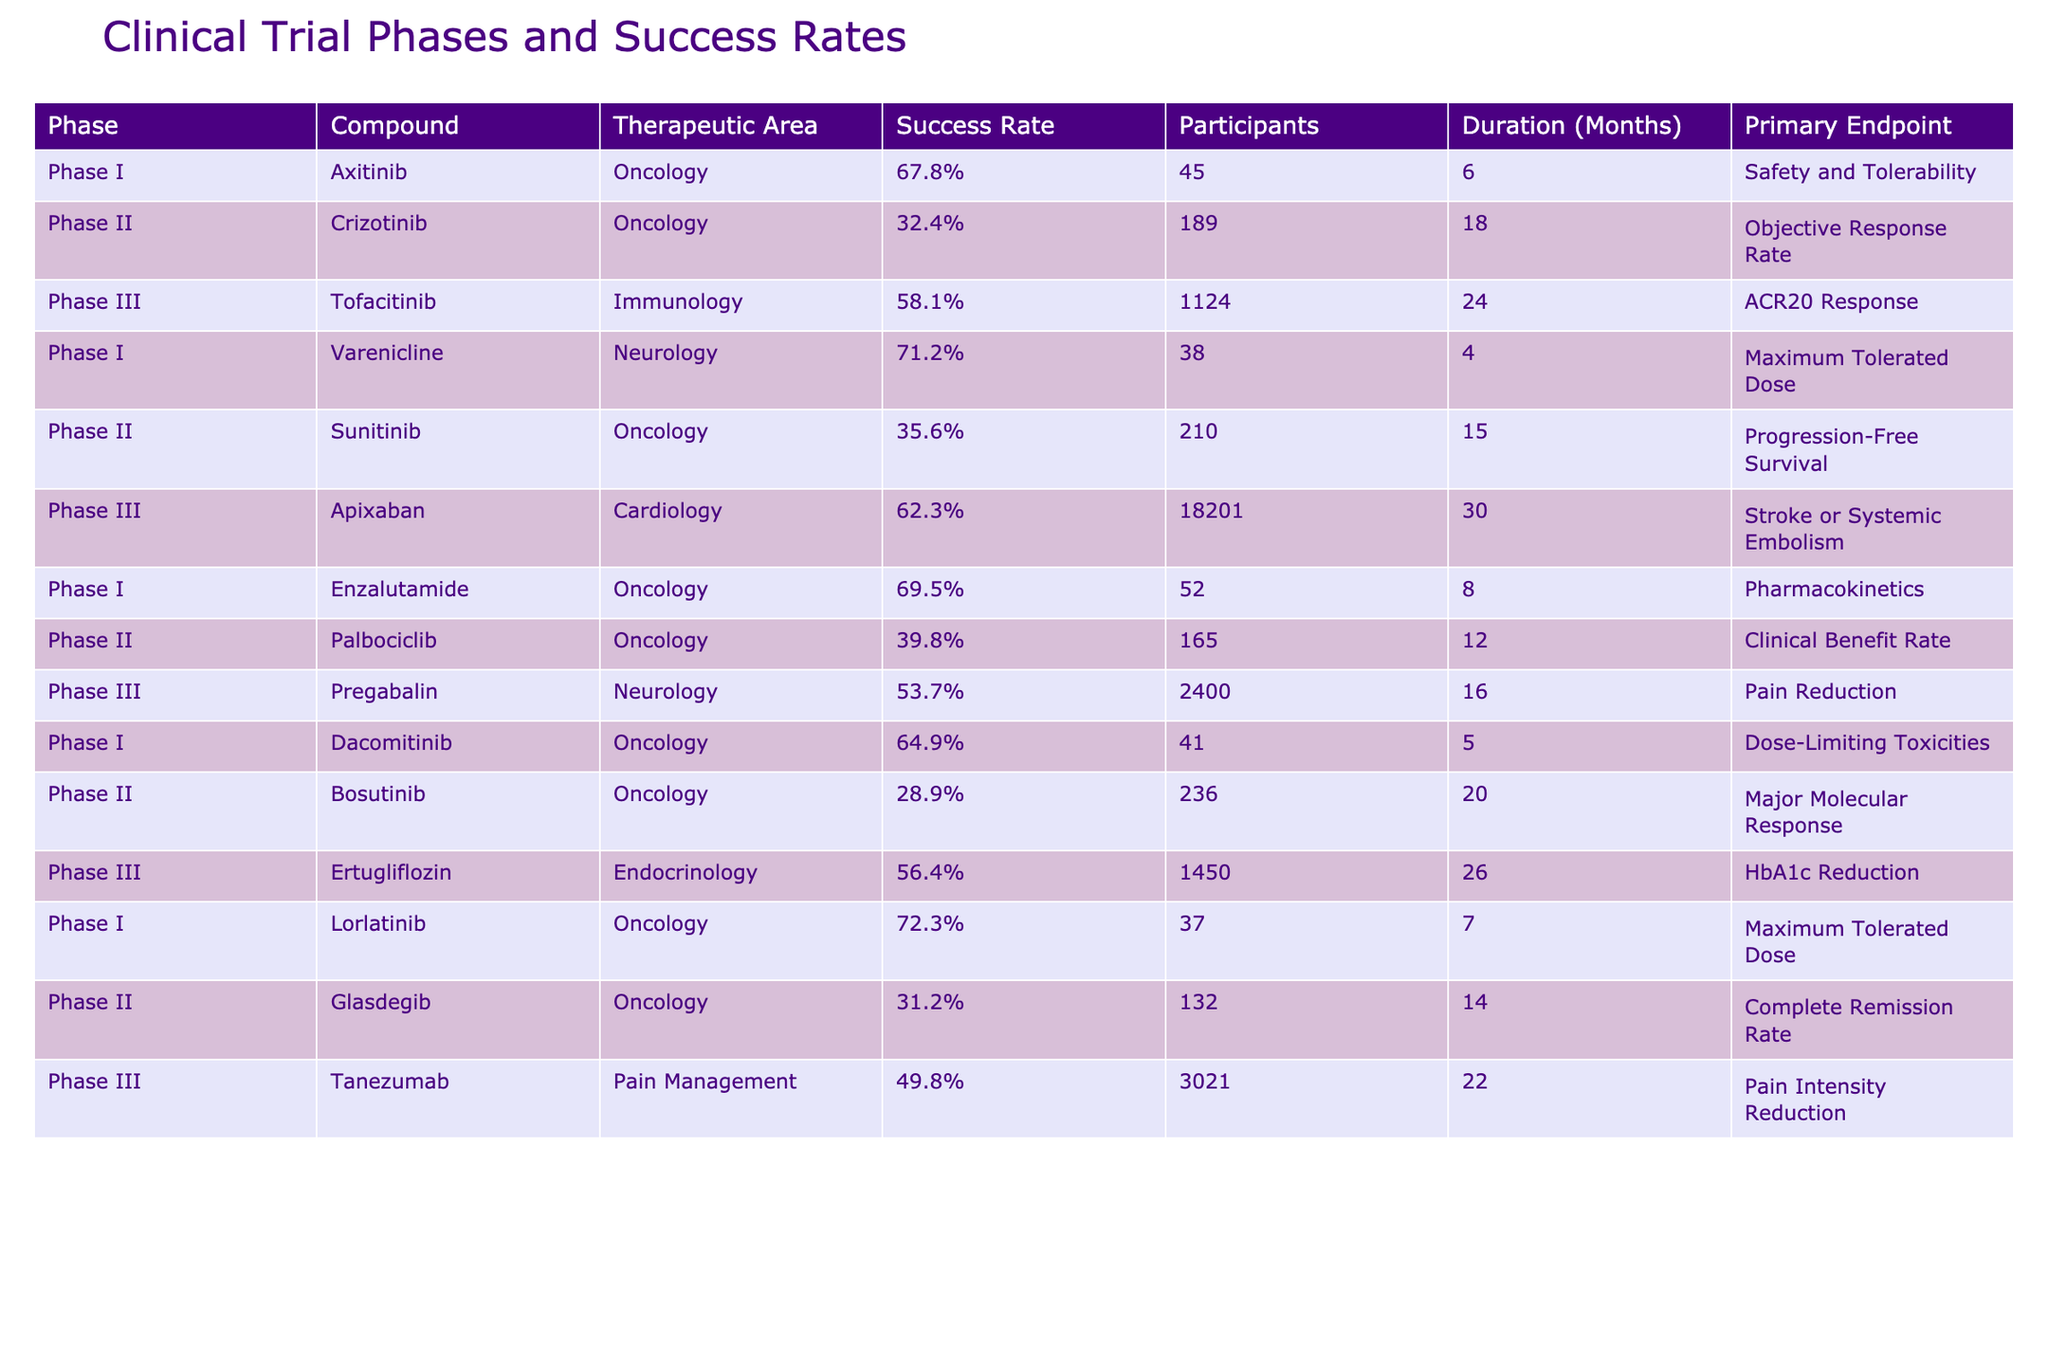What is the success rate of Enzalutamide in Phase I? The table displays the success rate for Enzalutamide in Phase I, which is listed as 69.5%.
Answer: 69.5% Which compound has the highest success rate in Phase I? By reviewing the Phase I data, we can see that Lorlatinib has the highest success rate at 72.3%.
Answer: 72.3% How many participants were involved in the Phase III trial of Apixaban? The table indicates that there were 18,201 participants in the Phase III trial of Apixaban.
Answer: 18,201 Is the success rate of Sunitinib in Phase II higher than that of Bosutinib? Sunitinib has a success rate of 35.6% while Bosutinib has a lower rate of 28.9%. Thus, Sunitinib's success rate is higher.
Answer: Yes What is the average success rate of compounds in Phase III? The success rates of Phase III compounds are 58.1%, 62.3%, 53.7%, 56.4%, and 49.8%. Adding these gives 280.3%, and dividing by 5 yields an average of 56.06%.
Answer: 56.06% Which therapeutic area has the highest number of participants in trials? By examining the data, Apixaban from Cardiology has the highest number of participants at 18,201, indication that this area has the largest participant count.
Answer: Cardiology How does the success rate of Crizotinib in Phase II compare to Tofacitinib in Phase III? Crizotinib has a success rate of 32.4%, while Tofacitinib has a higher success rate of 58.1%. Comparing these shows Tofacitinib is superior.
Answer: Tofacitinib is higher What is the total number of participants in all trials for compounds in the Oncology therapeutic area? The participants from the Oncology compounds are as follows: Axitinib (45), Crizotinib (189), Sunitinib (210), Enzalutamide (52), Dacomitinib (41), Lorlatinib (37), and Glasdegib (132). Summing these (45 + 189 + 210 + 52 + 41 + 37 + 132) results in 706 participants in total.
Answer: 706 Are all compounds in the Neurology domain included in Phase I and Phase III trials? The data reveals that Varenicline is in Phase I while Pregabalin is in Phase III, confirming that both compounds represent each of the phases in Neurology.
Answer: Yes What is the difference in success rates between Phase I and Phase II for the compound Varenicline and Sunitinib? Varenicline's success rate in Phase I is 71.2% and Sunitinib's in Phase II is 35.6%. The difference is calculated as 71.2% - 35.6% = 35.6%.
Answer: 35.6% 